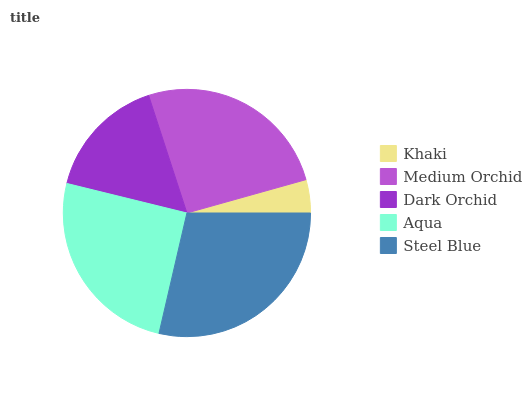Is Khaki the minimum?
Answer yes or no. Yes. Is Steel Blue the maximum?
Answer yes or no. Yes. Is Medium Orchid the minimum?
Answer yes or no. No. Is Medium Orchid the maximum?
Answer yes or no. No. Is Medium Orchid greater than Khaki?
Answer yes or no. Yes. Is Khaki less than Medium Orchid?
Answer yes or no. Yes. Is Khaki greater than Medium Orchid?
Answer yes or no. No. Is Medium Orchid less than Khaki?
Answer yes or no. No. Is Aqua the high median?
Answer yes or no. Yes. Is Aqua the low median?
Answer yes or no. Yes. Is Khaki the high median?
Answer yes or no. No. Is Dark Orchid the low median?
Answer yes or no. No. 